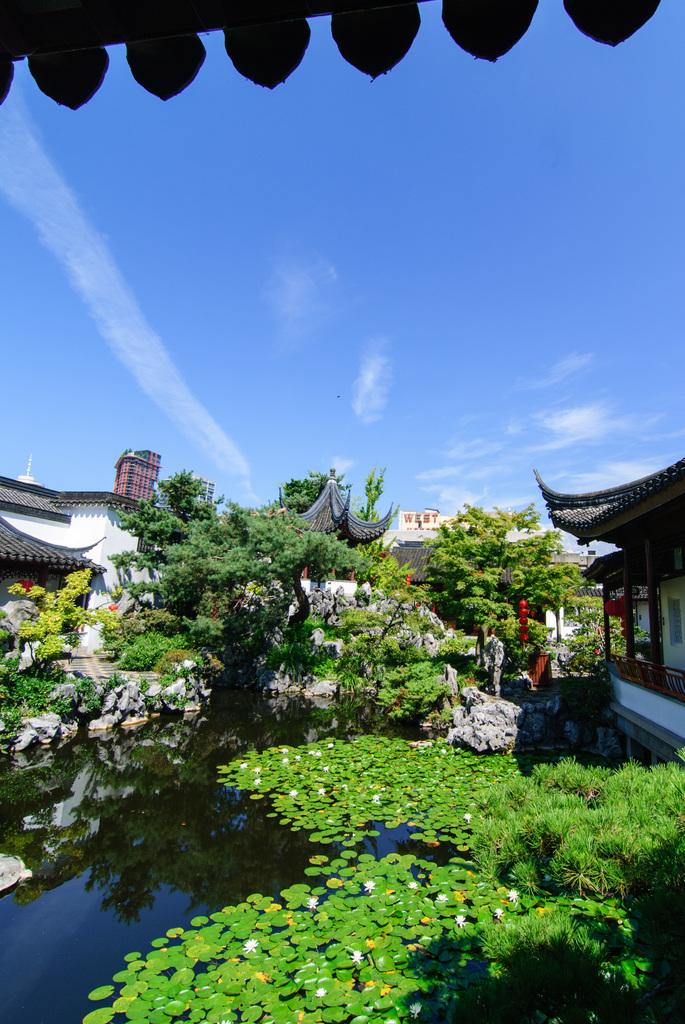What type of structures can be seen in the image? There are buildings in the image. What natural element is visible in the image? There is water visible in the image. What type of vegetation is present in the image? There are plants in the image. What is visible in the background of the image? The sky is visible in the image. What can be observed in the sky? Clouds are present in the sky. What type of bait is being used to catch the fish in the image? There are no fish or bait present in the image; it features buildings, water, plants, and clouds. What substance is being used to make the decision in the image? There is no decision-making process or substance depicted in the image. 